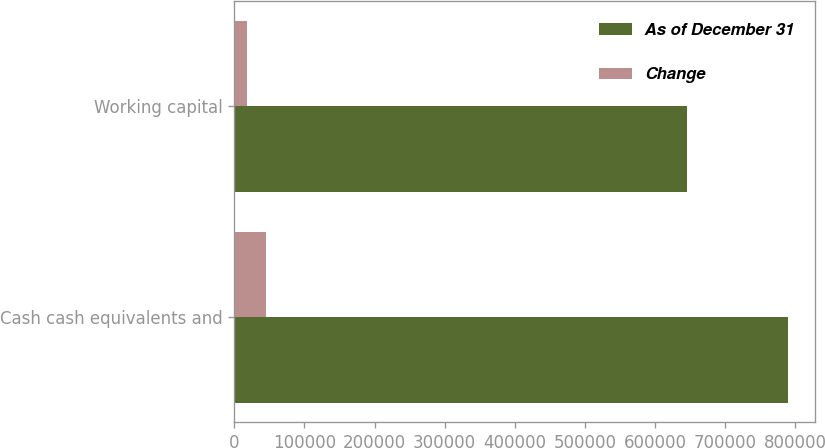<chart> <loc_0><loc_0><loc_500><loc_500><stacked_bar_chart><ecel><fcel>Cash cash equivalents and<fcel>Working capital<nl><fcel>As of December 31<fcel>788778<fcel>645394<nl><fcel>Change<fcel>45792<fcel>18229<nl></chart> 